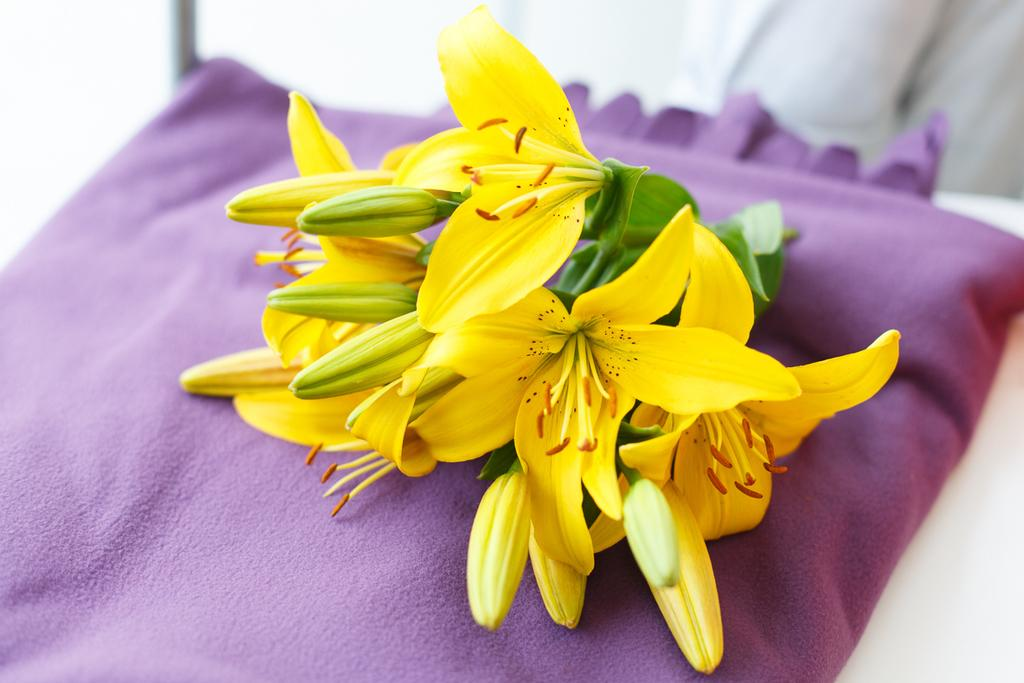What type of plant life is visible in the image? There are flowers, leaves, and buds in the image. What is the stage of the buds in the image? The buds are in the image, suggesting they are not yet fully bloomed flowers. What is the flowers, leaves, and buds resting on in the image? They are on a cloth in the image. What type of furniture is present in the image? There is a table at the bottom of the image. What type of lead can be seen connecting the flowers in the image? There is no lead connecting the flowers in the image; they are not wired or connected in any way. 